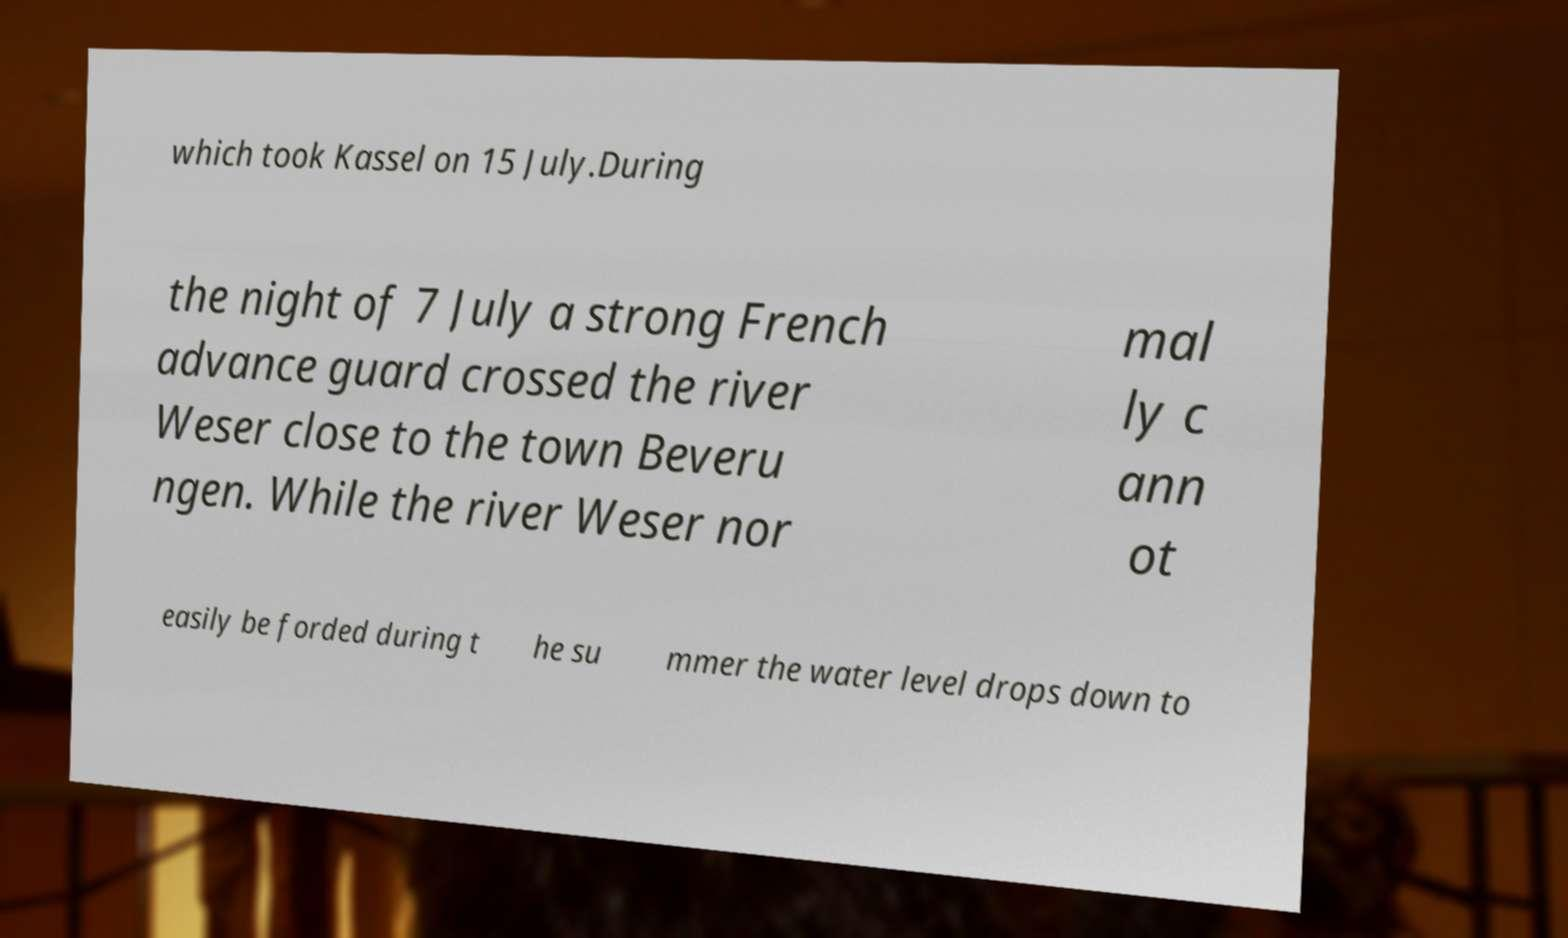I need the written content from this picture converted into text. Can you do that? which took Kassel on 15 July.During the night of 7 July a strong French advance guard crossed the river Weser close to the town Beveru ngen. While the river Weser nor mal ly c ann ot easily be forded during t he su mmer the water level drops down to 